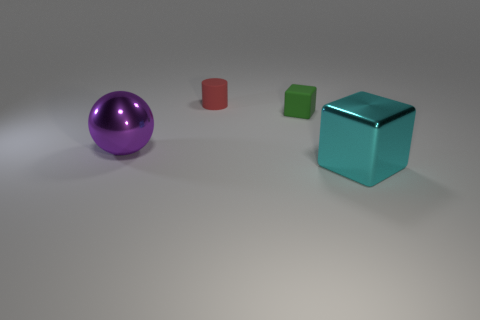Can you infer anything about the lighting of the scene from the shadows? The shadows in the image are relatively soft and exhibit a slight gradient, indicating that the lighting is soft and possibly diffused, with the primary light source coming from the right-hand side of the frame. This can be inferred from the direction and length of the shadows cast by the objects on the ground. The even illumination and lack of harsh shadows suggest an environment that is controlled or staged, as opposed to natural outdoor lighting. 